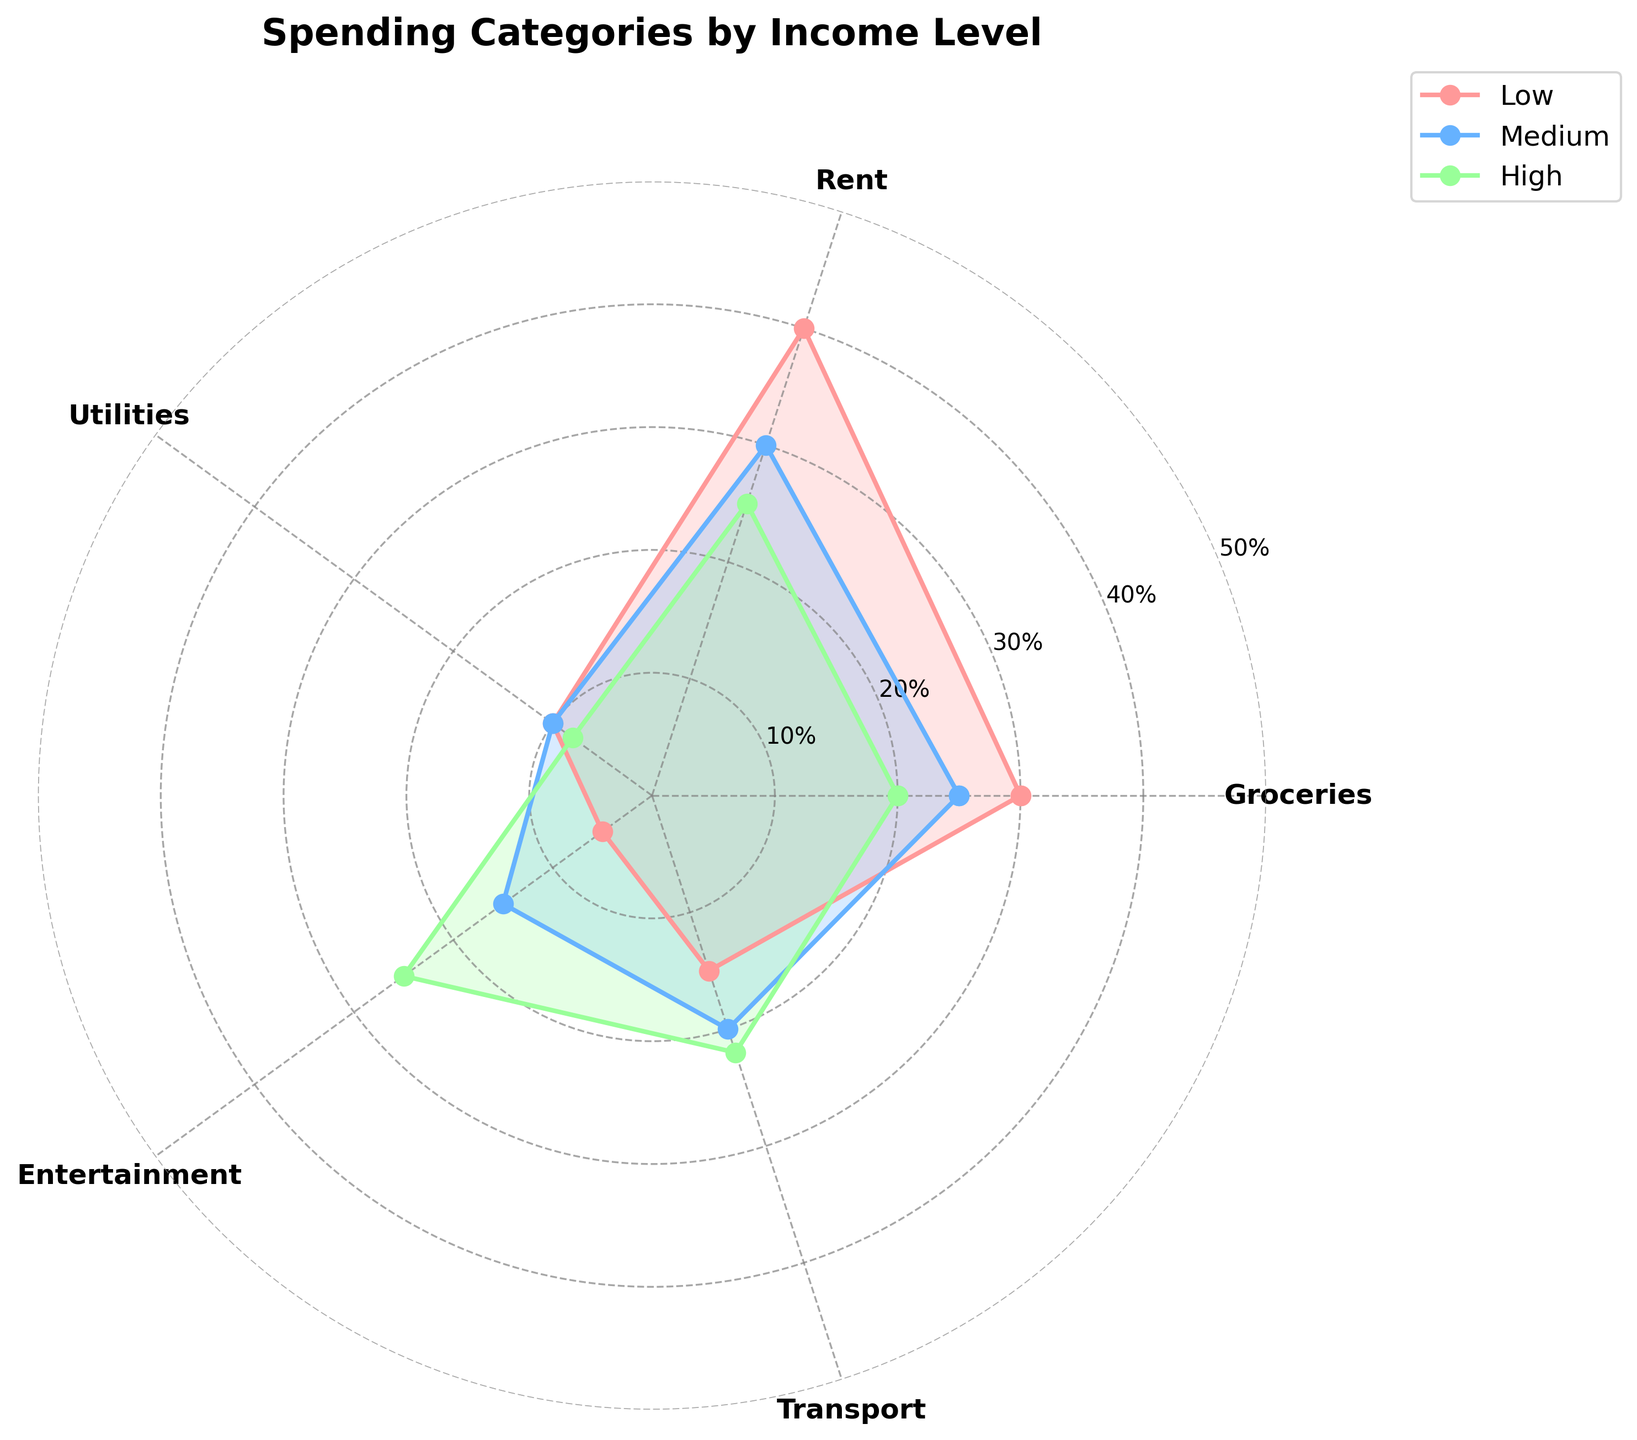What are the categories represented in the plot? The categories are displayed as the labels on the polar axes, which show the spending categories for different income levels.
Answer: Groceries, Rent, Utilities, Entertainment, Transport Which income level spends the most on rent? In the plot, look for the income level with the largest segment in the Rent category.
Answer: Low How much percentage does the medium income level spend on transport compared to utilities? Compare the percentage values in the Transport and Utilities categories for the Medium income level by looking at their respective segments.
Answer: Transport: 20%, Utilities: 10% What is the smallest percentage spent on any category by the high-income group? To find the smallest percentage, look at the high-income group's segments and identify the smallest value.
Answer: Utilities Which income level has the highest percentage expenditure on entertainment? Identify the income level whose segment in the Entertainment category is the largest.
Answer: High What are the combined percentages for groceries and transport for the low-income level? Sum the percentages for Groceries and Transport categories within the low-income group. 30% (Groceries) + 15% (Transport) = 45%
Answer: 45% By how much does the high-income group's percentage spending on entertainment exceed that of the low-income group? Subtract the low-income group's percentage for Entertainment from the high-income group's percentage. 25% (High) - 5% (Low)
Answer: 20% Which category sees a decrease in percentage expenditure as income increases from low to high? Compare the category percentages as income increases from low to high and identify the category where the percentage decreases.
Answer: Groceries What's the average percentage spent on utilities across all income levels? Sum the percentage values for Utilities across all income levels and divide by the number of income levels. (10% + 10% + 8%) / 3 = 9.33%
Answer: 9.33% Which spending category has the least variation in percentage across all income levels? Analyze the segments across all income levels and find the category with the smallest difference between the highest and lowest percentage values.
Answer: Utilities 